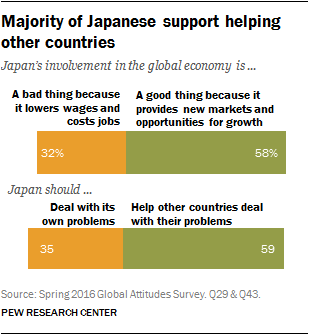List a handful of essential elements in this visual. The percentage value of the smallest orange bar is 32, and the answer to the question is yes. The difference between the sum of upper and lower bars is 4. 